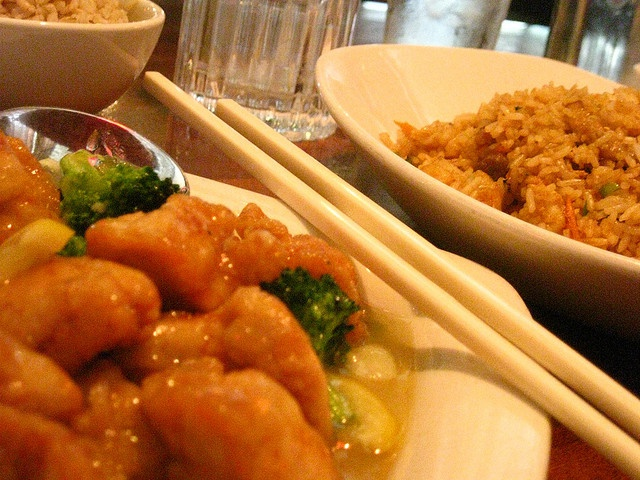Describe the objects in this image and their specific colors. I can see bowl in orange, tan, and red tones, dining table in orange, brown, khaki, and maroon tones, cup in orange, gray, tan, and olive tones, bowl in orange, brown, and maroon tones, and broccoli in orange, black, and olive tones in this image. 